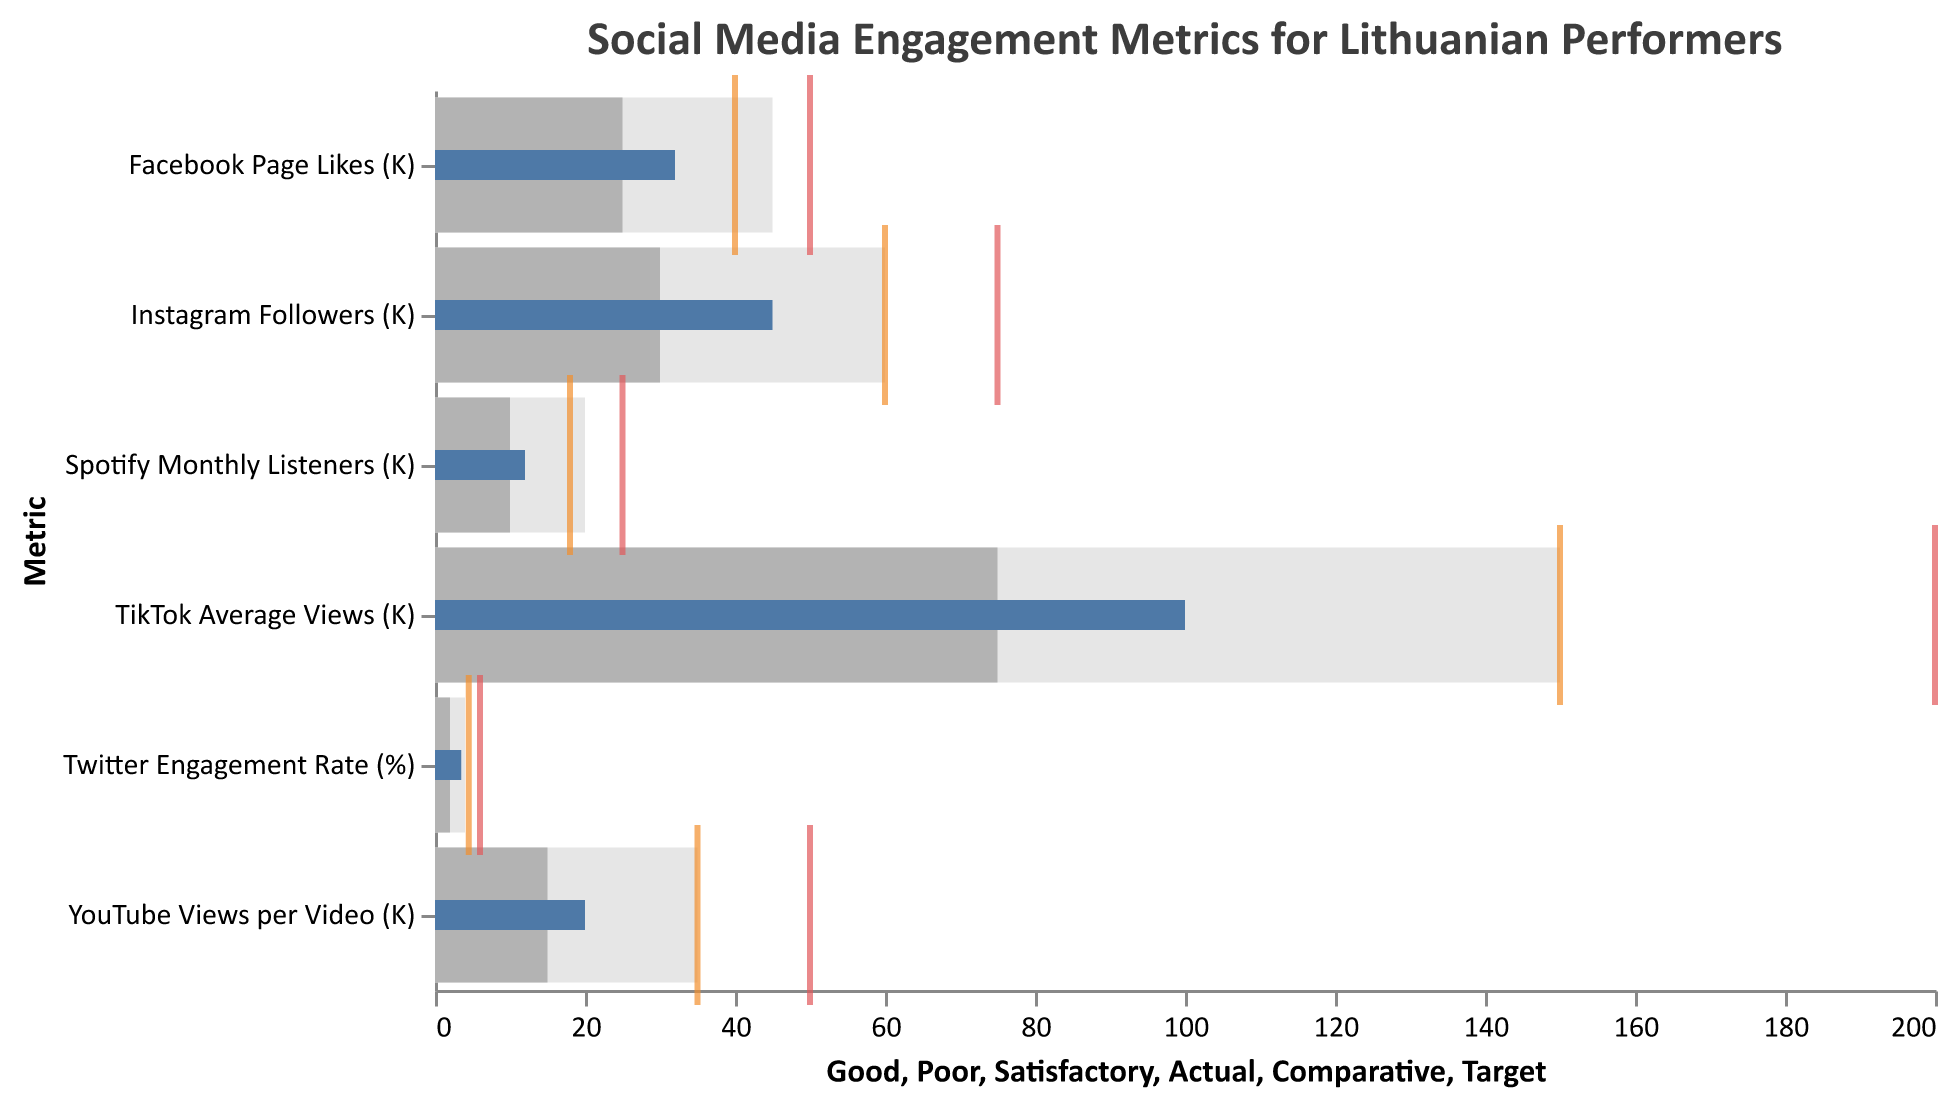What is the title of the figure? The title is located at the top of the figure. It helps identify what the data represents.
Answer: Social Media Engagement Metrics for Lithuanian Performers Which metric has the highest actual value? The actual values can be identified by the smaller blue bars. The metric with the largest blue bar is TikTok Average Views with an actual value of 100K.
Answer: TikTok Average Views (K) In which metric do Lithuanian performers meet the 'Good' range? The 'Good' range is shown by the lightest grey bars. The 'Actual' value needs to be within or exceed this range. Instagram Followers and TikTok Average Views are within the 'Good' range as their actual values of 45K and 100K both fall within the 'Good' range limits.
Answer: Instagram Followers (K), TikTok Average Views (K) Compare the 'Actual' values of Instagram Followers and Facebook Page Likes. Which one is higher? Observe the blue bars for both metrics; the actual value for Instagram Followers is 45K, and for Facebook Page Likes, it is 32K. The Instagram Followers metric has a higher actual value.
Answer: Instagram Followers (K) Which metric is closest to its 'Comparative' value? Look at the ticks that indicate the 'Comparative' values, with TikTok Average Views 'Actual' value (100K) being closest to its 'Comparative' value (150K) among all metrics.
Answer: TikTok Average Views (K) How far is the 'Actual' value from the 'Target' value for YouTube Views per Video? The 'Actual' value is 20K and the 'Target' value is 50K. To find the difference: 50K - 20K = 30K.
Answer: 30K Identify a metric where the 'Actual' value is in the 'Satisfactory' but not in the 'Good' range. Facebook Page Likes has an actual value of 32K which is within the satisfactory range of 25K–45K but does not meet the 'Good' range starting at 45K.
Answer: Facebook Page Likes (K) Does the Twitter Engagement Rate exceed the 'Good' range threshold? The 'Good' range for Twitter Engagement Rate starts at 4%, but its actual value is 3.5%. Therefore, it does not exceed the 'Good' range.
Answer: No What is the difference between the 'Comparative' and 'Target' values for Spotify Monthly Listeners? The 'Comparative' value is 18K, and the 'Target' value is 25K. The difference is 25K - 18K = 7K.
Answer: 7K 